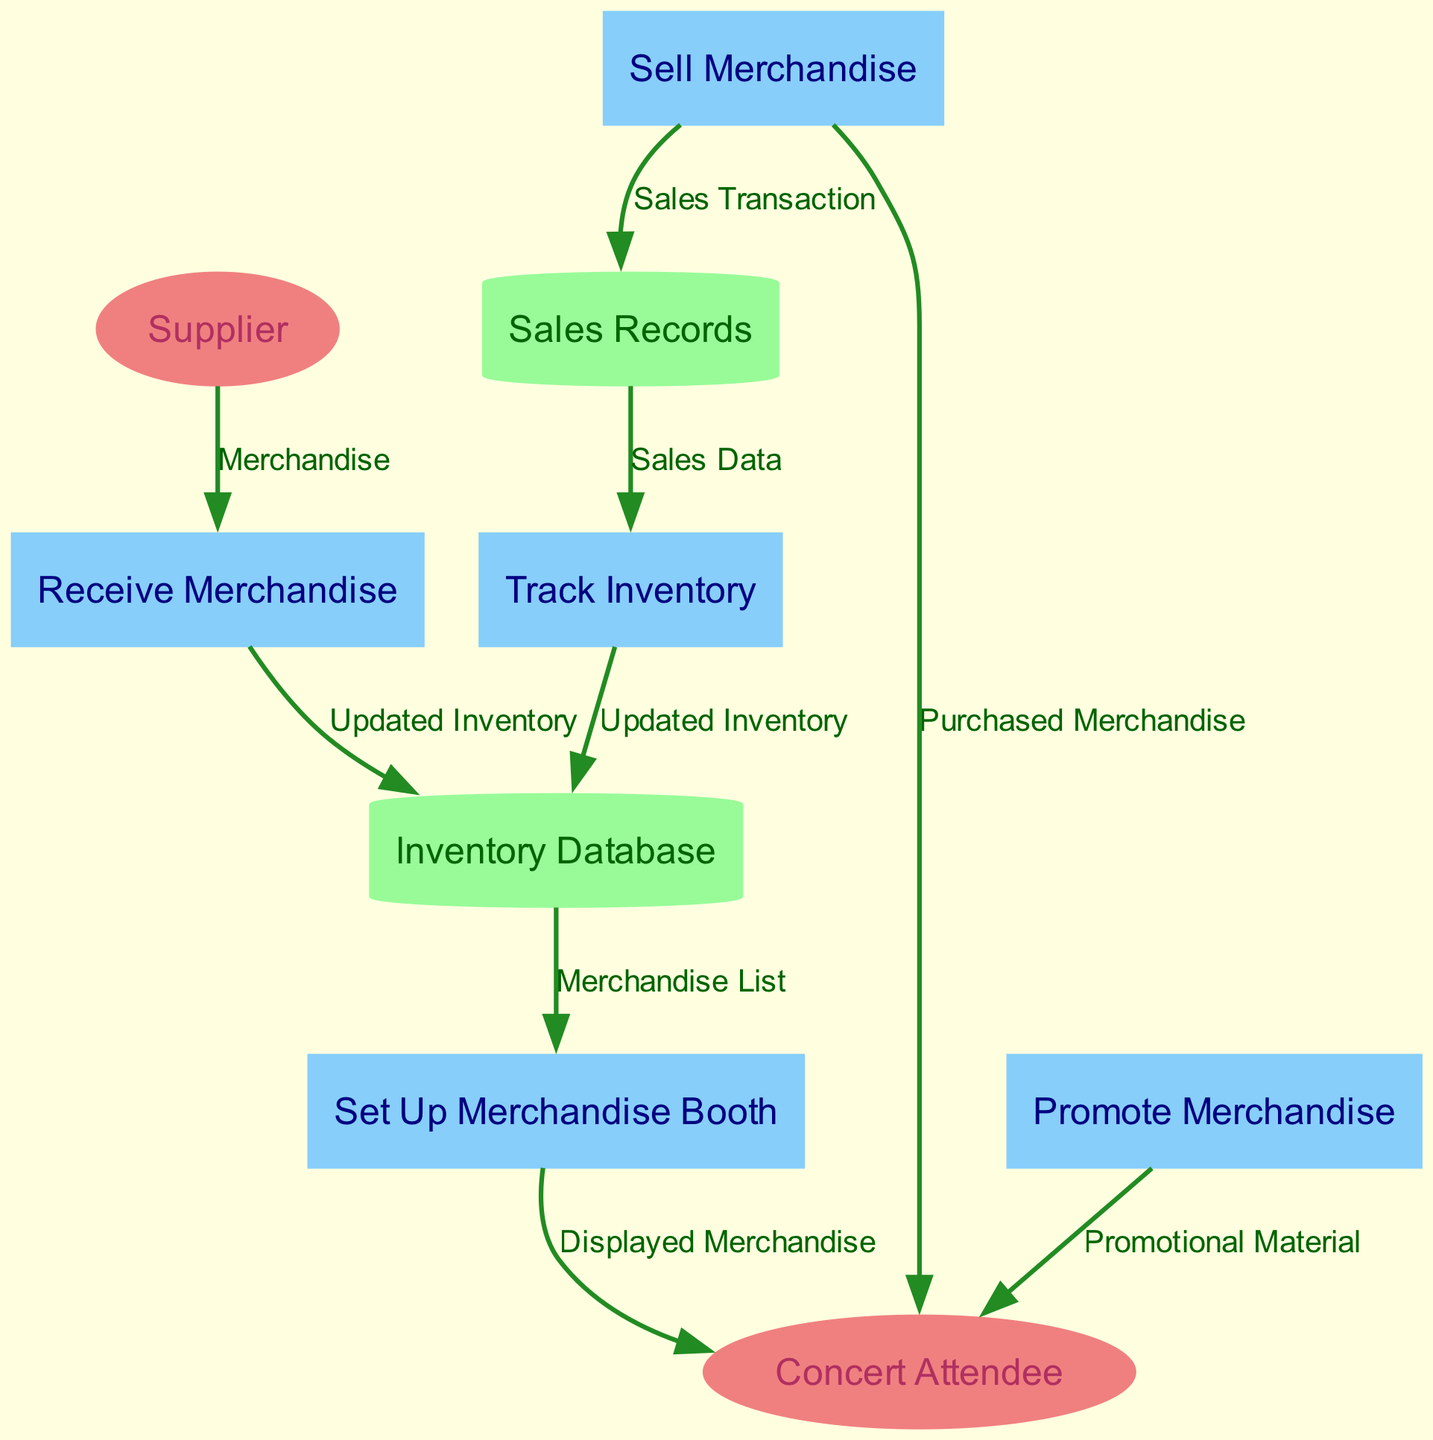What is the role of the Concert Attendee in the diagram? The Concert Attendee is an external entity in the Data Flow Diagram that interacts with various processes, receiving displayed merchandise and purchasing items. They represent the target audience at local gigs interested in buying merchandise.
Answer: Person attending the gig How many processes are defined in the diagram? By counting the distinct processes listed in the diagram, we note "Receive Merchandise," "Set Up Merchandise Booth," "Promote Merchandise," "Sell Merchandise," and "Track Inventory" as individual processes. This gives us a total of five processes.
Answer: Five What data flows from the Supplier to the Receive Merchandise process? The diagram specifies that the data flowing from the Supplier to the Receive Merchandise process is the Merchandise itself. This indicates the initial step in receiving inventory.
Answer: Merchandise Which process leads to the displayed merchandise seen by the Concert Attendee? The flow of data from the "Set Up Merchandise Booth" process indicates that this is where the displayed merchandise is created and presented to the Concert Attendee. Thus, the displayed merchandise results from this process.
Answer: Set Up Merchandise Booth How often is the Inventory Database updated in the diagram? The Inventory Database is updated in two instances: once after receiving merchandise (from the Receive Merchandise process) and again based on the outputs from the Track Inventory process, which shows that updates occur multiple times throughout the selling process.
Answer: Multiple times What is the final outcome of the Sell Merchandise process? The Sell Merchandise process culminates in the Concert Attendee receiving Purchased Merchandise, indicating a successful transaction where they acquire the items being sold.
Answer: Purchased Merchandise Which data store contains the record of sales transactions? In the diagram, the data store responsible for maintaining the record of sales transactions made during gigs is labeled as Sales Records. This store keeps track of every sale that occurs.
Answer: Sales Records How does the Promote Merchandise process communicate with the Concert Attendee? The Promote Merchandise process interacts with the Concert Attendee by providing Promotional Material, which may include announcements through social media or during the gig, aimed at encouraging merchandise purchases.
Answer: Promotional Material What is the purpose of the Track Inventory process? The Track Inventory process monitors the merchandise sold and adjusts stock levels accordingly, ensuring that there is accurate accounting for sales data and remaining inventory, which helps maintain a clear record of inventory status.
Answer: Monitor stock levels 